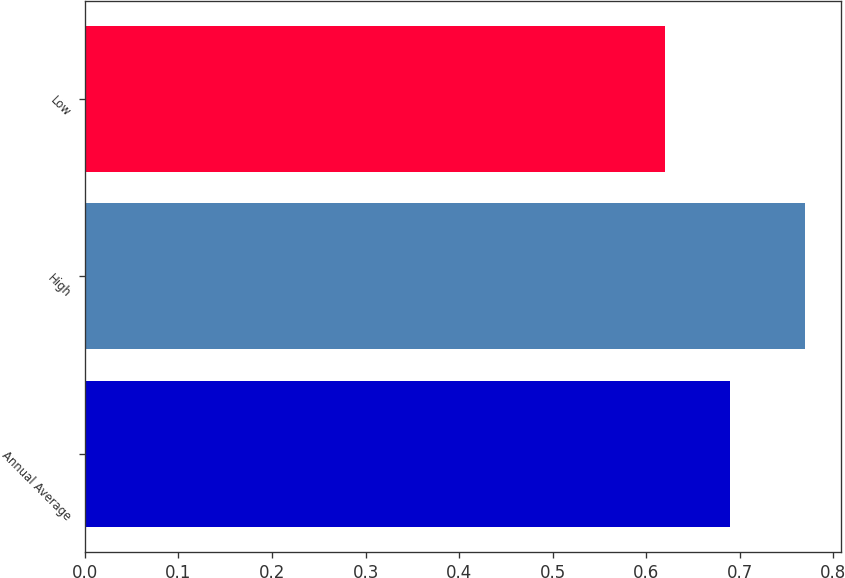<chart> <loc_0><loc_0><loc_500><loc_500><bar_chart><fcel>Annual Average<fcel>High<fcel>Low<nl><fcel>0.69<fcel>0.77<fcel>0.62<nl></chart> 